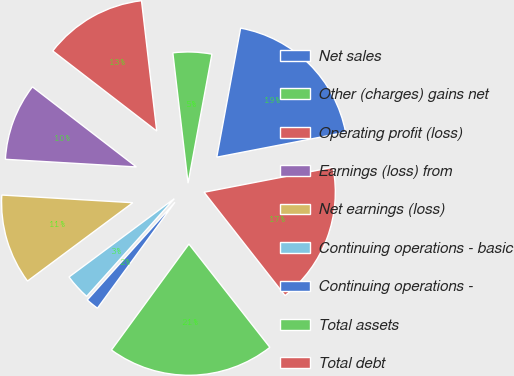<chart> <loc_0><loc_0><loc_500><loc_500><pie_chart><fcel>Net sales<fcel>Other (charges) gains net<fcel>Operating profit (loss)<fcel>Earnings (loss) from<fcel>Net earnings (loss)<fcel>Continuing operations - basic<fcel>Continuing operations -<fcel>Total assets<fcel>Total debt<nl><fcel>19.05%<fcel>4.76%<fcel>12.7%<fcel>9.52%<fcel>11.11%<fcel>3.18%<fcel>1.59%<fcel>20.63%<fcel>17.46%<nl></chart> 